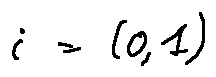<formula> <loc_0><loc_0><loc_500><loc_500>i = ( 0 , 1 )</formula> 